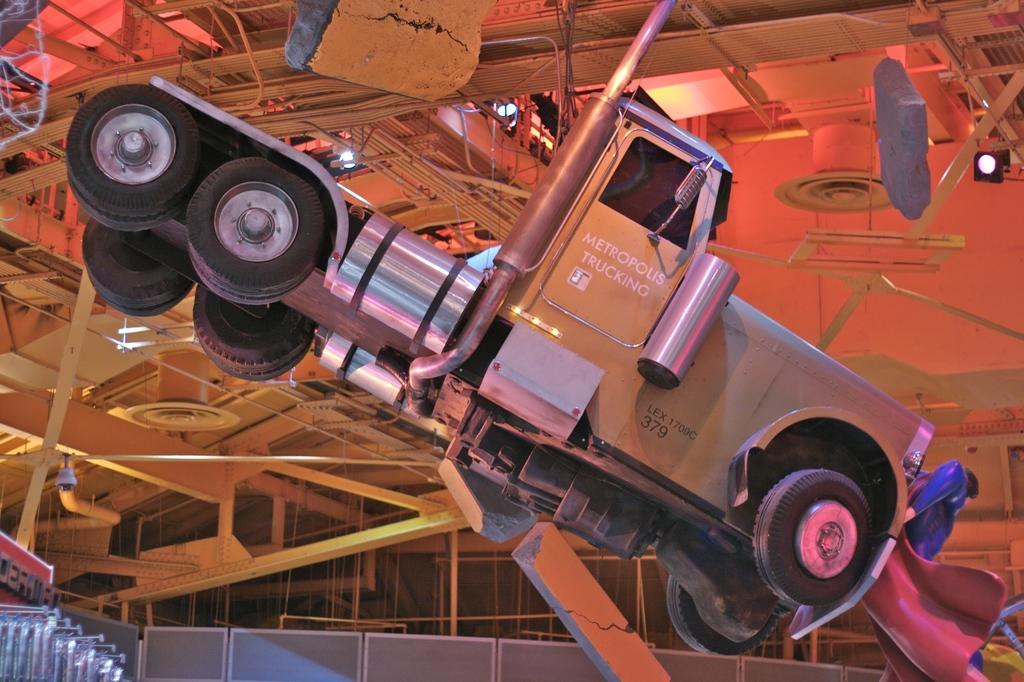Can you describe this image briefly? In this picture we can observe a vehicle. We can observe some rods to the ceiling. We can observe grey color wall here. 